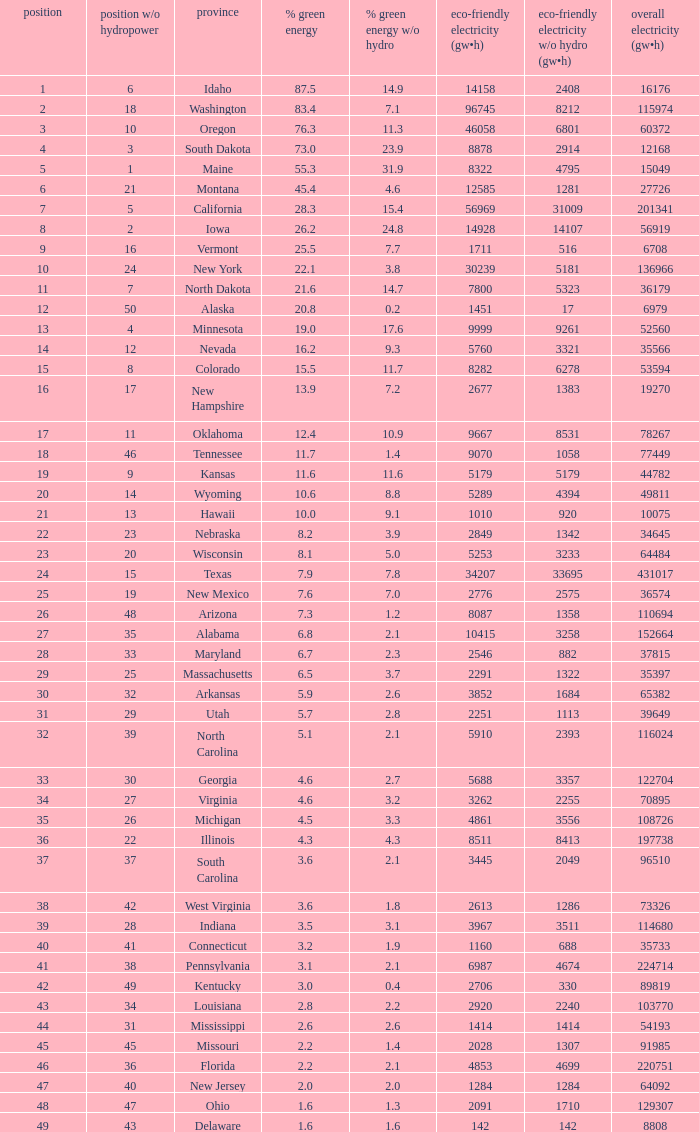Parse the table in full. {'header': ['position', 'position w/o hydropower', 'province', '% green energy', '% green energy w/o hydro', 'eco-friendly electricity (gw•h)', 'eco-friendly electricity w/o hydro (gw•h)', 'overall electricity (gw•h)'], 'rows': [['1', '6', 'Idaho', '87.5', '14.9', '14158', '2408', '16176'], ['2', '18', 'Washington', '83.4', '7.1', '96745', '8212', '115974'], ['3', '10', 'Oregon', '76.3', '11.3', '46058', '6801', '60372'], ['4', '3', 'South Dakota', '73.0', '23.9', '8878', '2914', '12168'], ['5', '1', 'Maine', '55.3', '31.9', '8322', '4795', '15049'], ['6', '21', 'Montana', '45.4', '4.6', '12585', '1281', '27726'], ['7', '5', 'California', '28.3', '15.4', '56969', '31009', '201341'], ['8', '2', 'Iowa', '26.2', '24.8', '14928', '14107', '56919'], ['9', '16', 'Vermont', '25.5', '7.7', '1711', '516', '6708'], ['10', '24', 'New York', '22.1', '3.8', '30239', '5181', '136966'], ['11', '7', 'North Dakota', '21.6', '14.7', '7800', '5323', '36179'], ['12', '50', 'Alaska', '20.8', '0.2', '1451', '17', '6979'], ['13', '4', 'Minnesota', '19.0', '17.6', '9999', '9261', '52560'], ['14', '12', 'Nevada', '16.2', '9.3', '5760', '3321', '35566'], ['15', '8', 'Colorado', '15.5', '11.7', '8282', '6278', '53594'], ['16', '17', 'New Hampshire', '13.9', '7.2', '2677', '1383', '19270'], ['17', '11', 'Oklahoma', '12.4', '10.9', '9667', '8531', '78267'], ['18', '46', 'Tennessee', '11.7', '1.4', '9070', '1058', '77449'], ['19', '9', 'Kansas', '11.6', '11.6', '5179', '5179', '44782'], ['20', '14', 'Wyoming', '10.6', '8.8', '5289', '4394', '49811'], ['21', '13', 'Hawaii', '10.0', '9.1', '1010', '920', '10075'], ['22', '23', 'Nebraska', '8.2', '3.9', '2849', '1342', '34645'], ['23', '20', 'Wisconsin', '8.1', '5.0', '5253', '3233', '64484'], ['24', '15', 'Texas', '7.9', '7.8', '34207', '33695', '431017'], ['25', '19', 'New Mexico', '7.6', '7.0', '2776', '2575', '36574'], ['26', '48', 'Arizona', '7.3', '1.2', '8087', '1358', '110694'], ['27', '35', 'Alabama', '6.8', '2.1', '10415', '3258', '152664'], ['28', '33', 'Maryland', '6.7', '2.3', '2546', '882', '37815'], ['29', '25', 'Massachusetts', '6.5', '3.7', '2291', '1322', '35397'], ['30', '32', 'Arkansas', '5.9', '2.6', '3852', '1684', '65382'], ['31', '29', 'Utah', '5.7', '2.8', '2251', '1113', '39649'], ['32', '39', 'North Carolina', '5.1', '2.1', '5910', '2393', '116024'], ['33', '30', 'Georgia', '4.6', '2.7', '5688', '3357', '122704'], ['34', '27', 'Virginia', '4.6', '3.2', '3262', '2255', '70895'], ['35', '26', 'Michigan', '4.5', '3.3', '4861', '3556', '108726'], ['36', '22', 'Illinois', '4.3', '4.3', '8511', '8413', '197738'], ['37', '37', 'South Carolina', '3.6', '2.1', '3445', '2049', '96510'], ['38', '42', 'West Virginia', '3.6', '1.8', '2613', '1286', '73326'], ['39', '28', 'Indiana', '3.5', '3.1', '3967', '3511', '114680'], ['40', '41', 'Connecticut', '3.2', '1.9', '1160', '688', '35733'], ['41', '38', 'Pennsylvania', '3.1', '2.1', '6987', '4674', '224714'], ['42', '49', 'Kentucky', '3.0', '0.4', '2706', '330', '89819'], ['43', '34', 'Louisiana', '2.8', '2.2', '2920', '2240', '103770'], ['44', '31', 'Mississippi', '2.6', '2.6', '1414', '1414', '54193'], ['45', '45', 'Missouri', '2.2', '1.4', '2028', '1307', '91985'], ['46', '36', 'Florida', '2.2', '2.1', '4853', '4699', '220751'], ['47', '40', 'New Jersey', '2.0', '2.0', '1284', '1284', '64092'], ['48', '47', 'Ohio', '1.6', '1.3', '2091', '1710', '129307'], ['49', '43', 'Delaware', '1.6', '1.6', '142', '142', '8808']]} What is the amount of renewable electricity without hydrogen power when the percentage of renewable energy is 83.4? 8212.0. 